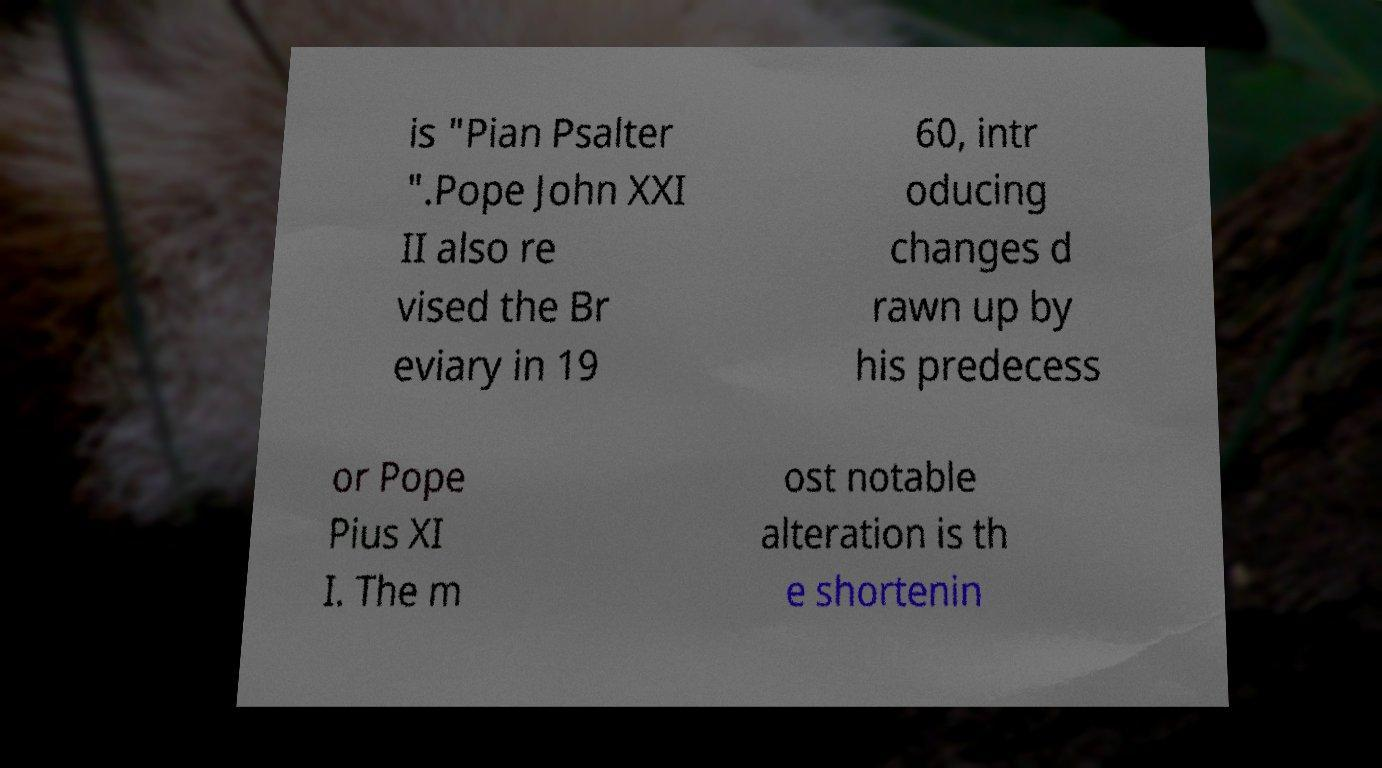For documentation purposes, I need the text within this image transcribed. Could you provide that? is "Pian Psalter ".Pope John XXI II also re vised the Br eviary in 19 60, intr oducing changes d rawn up by his predecess or Pope Pius XI I. The m ost notable alteration is th e shortenin 